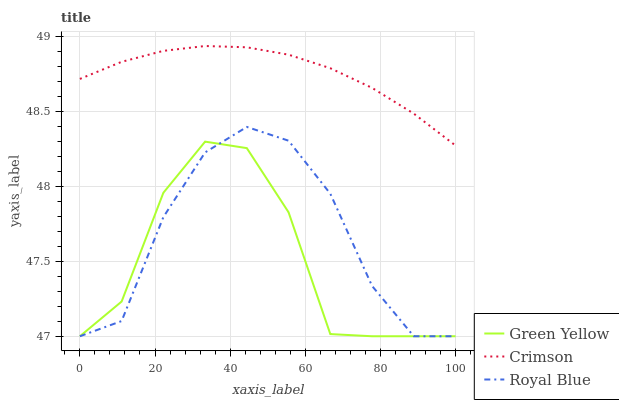Does Green Yellow have the minimum area under the curve?
Answer yes or no. Yes. Does Crimson have the maximum area under the curve?
Answer yes or no. Yes. Does Royal Blue have the minimum area under the curve?
Answer yes or no. No. Does Royal Blue have the maximum area under the curve?
Answer yes or no. No. Is Crimson the smoothest?
Answer yes or no. Yes. Is Green Yellow the roughest?
Answer yes or no. Yes. Is Royal Blue the smoothest?
Answer yes or no. No. Is Royal Blue the roughest?
Answer yes or no. No. Does Royal Blue have the lowest value?
Answer yes or no. Yes. Does Crimson have the highest value?
Answer yes or no. Yes. Does Royal Blue have the highest value?
Answer yes or no. No. Is Green Yellow less than Crimson?
Answer yes or no. Yes. Is Crimson greater than Royal Blue?
Answer yes or no. Yes. Does Royal Blue intersect Green Yellow?
Answer yes or no. Yes. Is Royal Blue less than Green Yellow?
Answer yes or no. No. Is Royal Blue greater than Green Yellow?
Answer yes or no. No. Does Green Yellow intersect Crimson?
Answer yes or no. No. 